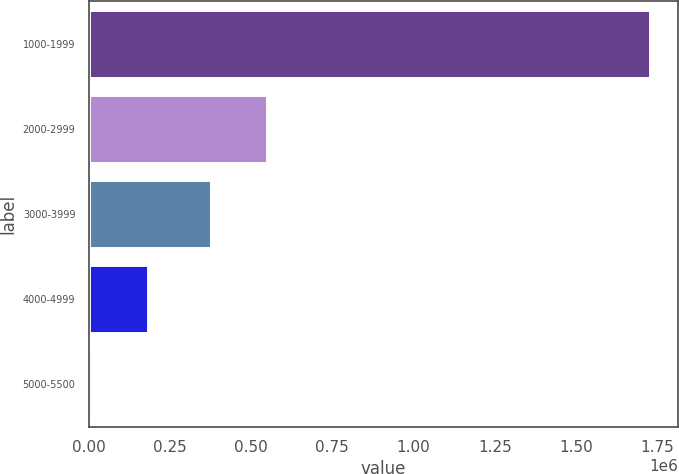<chart> <loc_0><loc_0><loc_500><loc_500><bar_chart><fcel>1000-1999<fcel>2000-2999<fcel>3000-3999<fcel>4000-4999<fcel>5000-5500<nl><fcel>1.72706e+06<fcel>549149<fcel>377493<fcel>182156<fcel>10500<nl></chart> 